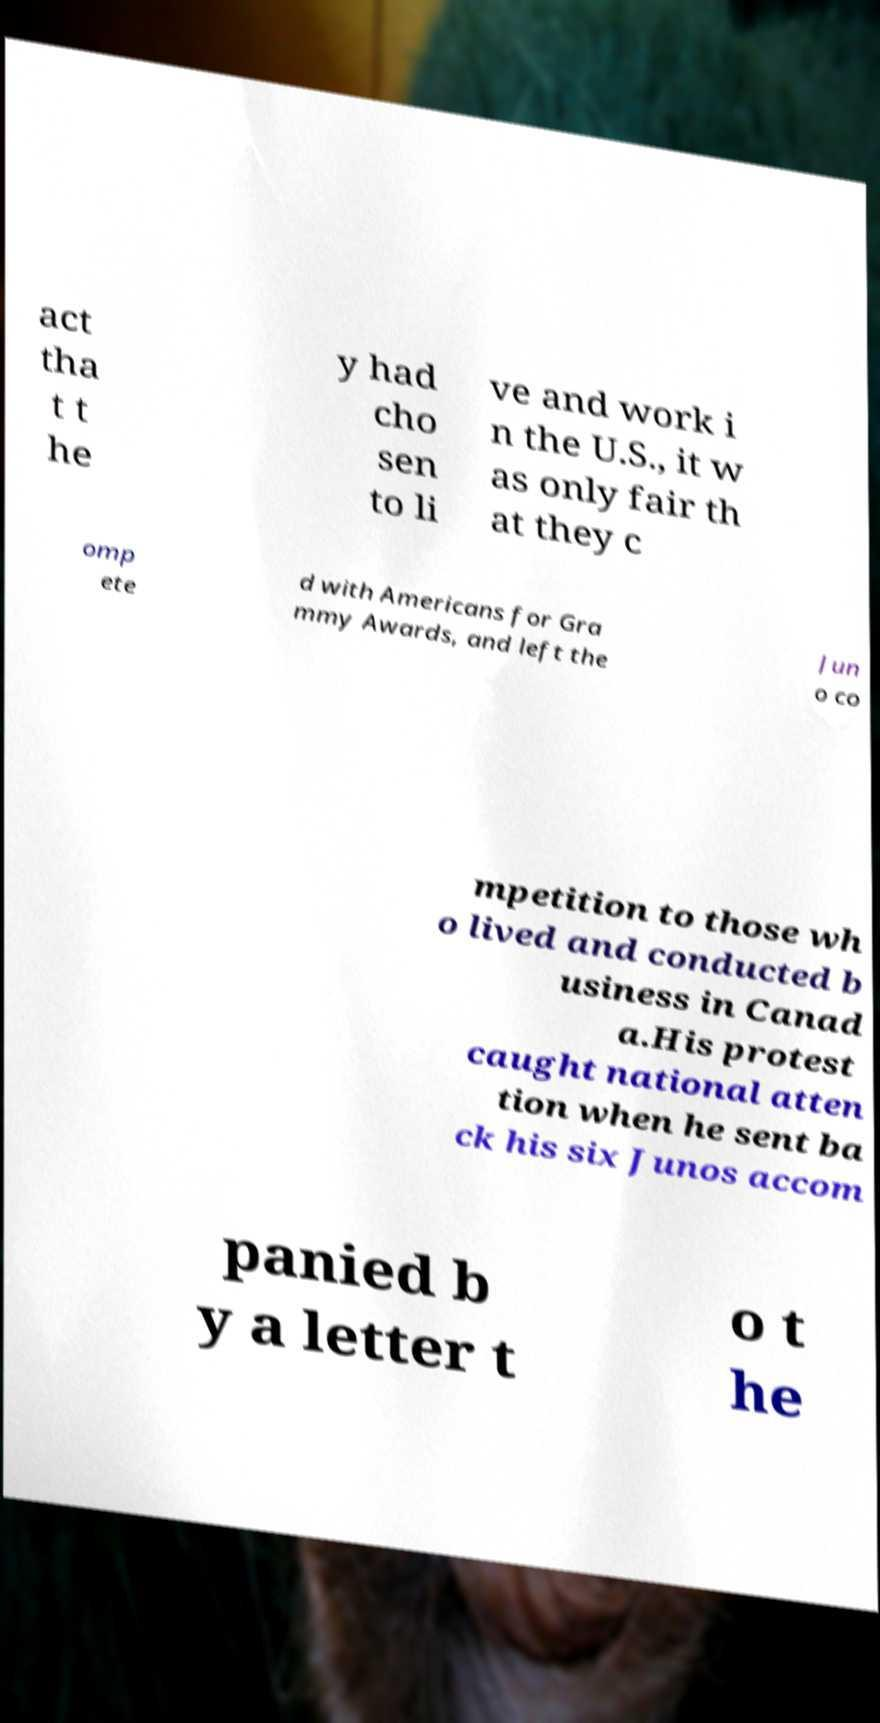Could you extract and type out the text from this image? act tha t t he y had cho sen to li ve and work i n the U.S., it w as only fair th at they c omp ete d with Americans for Gra mmy Awards, and left the Jun o co mpetition to those wh o lived and conducted b usiness in Canad a.His protest caught national atten tion when he sent ba ck his six Junos accom panied b y a letter t o t he 